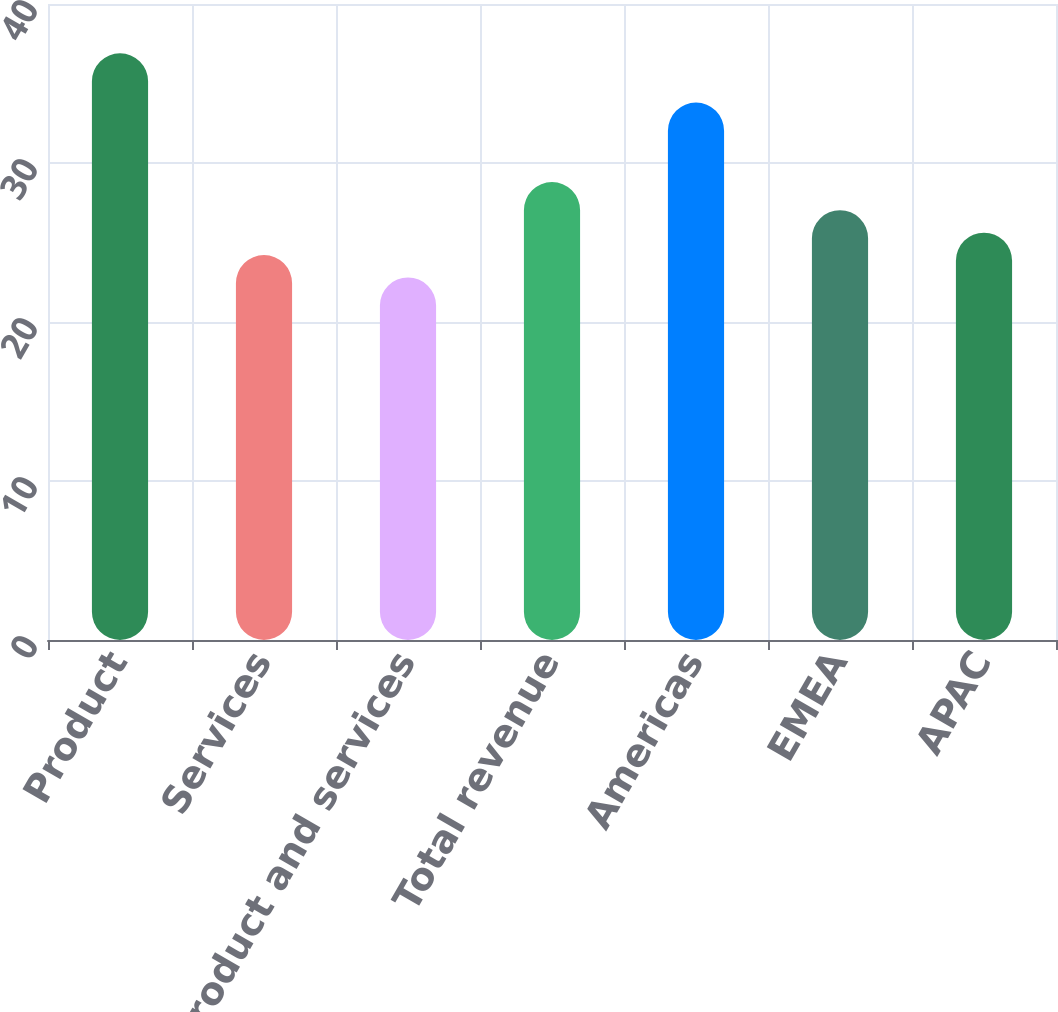Convert chart. <chart><loc_0><loc_0><loc_500><loc_500><bar_chart><fcel>Product<fcel>Services<fcel>Ratable product and services<fcel>Total revenue<fcel>Americas<fcel>EMEA<fcel>APAC<nl><fcel>36.9<fcel>24.21<fcel>22.8<fcel>28.8<fcel>33.8<fcel>27.03<fcel>25.62<nl></chart> 